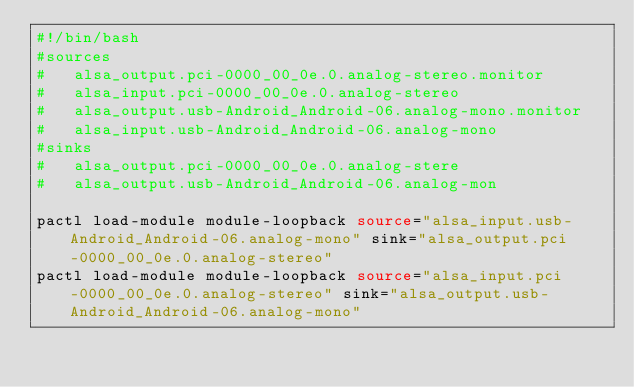<code> <loc_0><loc_0><loc_500><loc_500><_Bash_>#!/bin/bash
#sources
#	alsa_output.pci-0000_00_0e.0.analog-stereo.monitor
#	alsa_input.pci-0000_00_0e.0.analog-stereo
#	alsa_output.usb-Android_Android-06.analog-mono.monitor
#	alsa_input.usb-Android_Android-06.analog-mono
#sinks
#	alsa_output.pci-0000_00_0e.0.analog-stere
#	alsa_output.usb-Android_Android-06.analog-mon

pactl load-module module-loopback source="alsa_input.usb-Android_Android-06.analog-mono" sink="alsa_output.pci-0000_00_0e.0.analog-stereo"
pactl load-module module-loopback source="alsa_input.pci-0000_00_0e.0.analog-stereo" sink="alsa_output.usb-Android_Android-06.analog-mono" 

</code> 